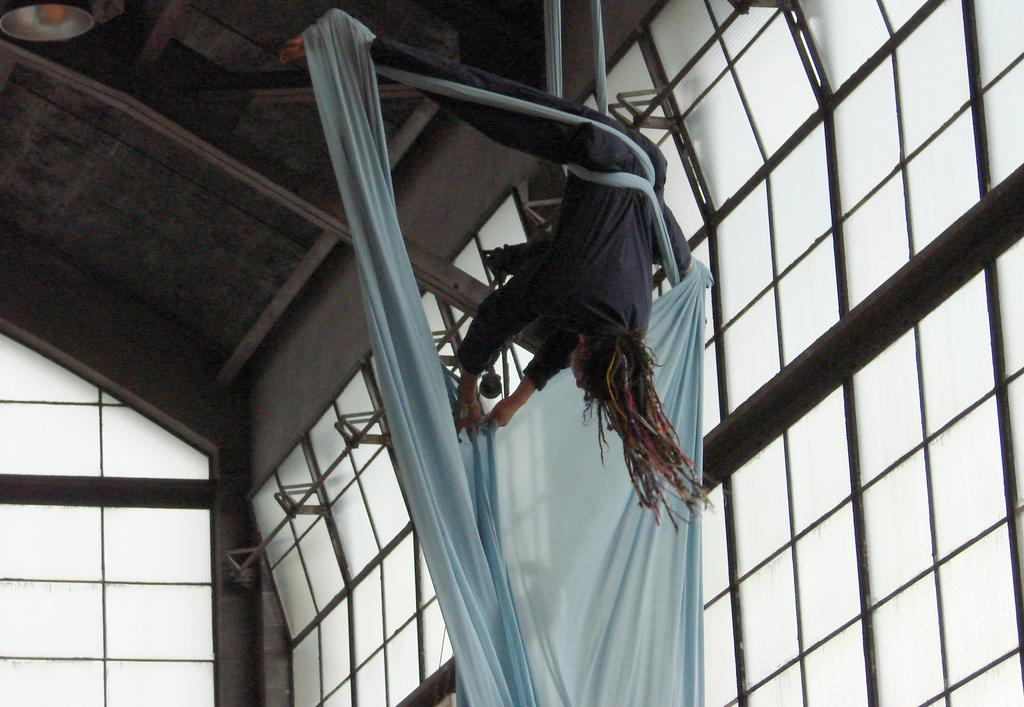What is the main activity being performed in the image? A person is performing aerial acrobatics. What type of structure is visible in the image? There are glass windows on the sides and a ceiling in the image. What letter is being steamed on the ceiling in the image? There is no letter being steamed on the ceiling in the image. 